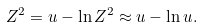<formula> <loc_0><loc_0><loc_500><loc_500>Z ^ { 2 } = u - \ln Z ^ { 2 } \approx u - \ln u .</formula> 